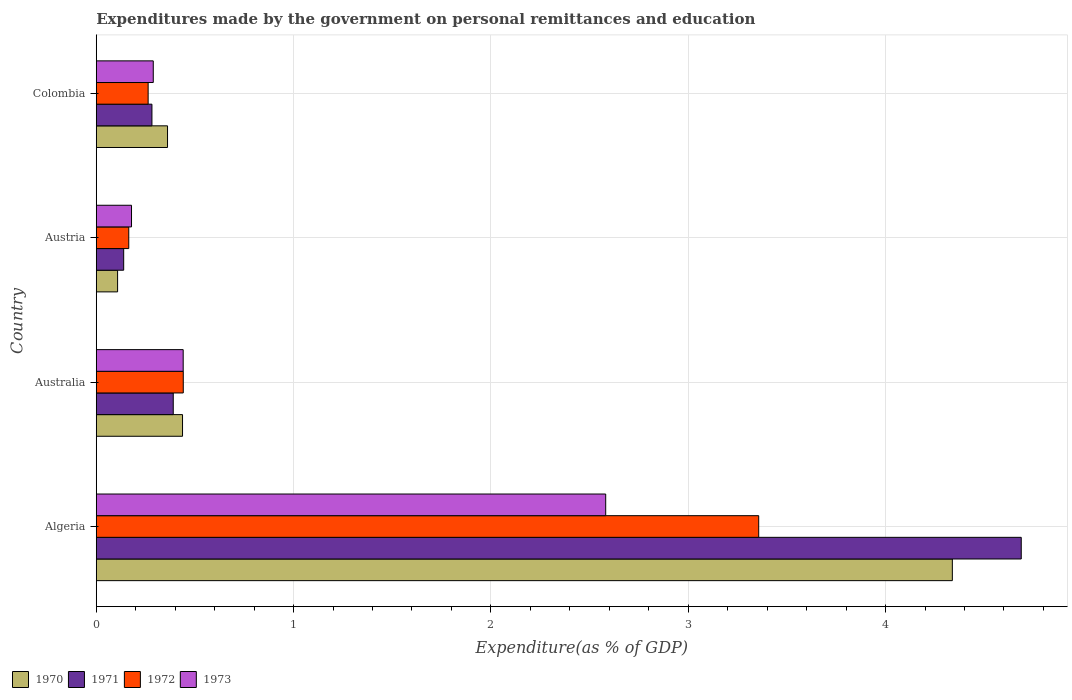How many groups of bars are there?
Ensure brevity in your answer.  4. How many bars are there on the 3rd tick from the bottom?
Your answer should be very brief. 4. In how many cases, is the number of bars for a given country not equal to the number of legend labels?
Provide a short and direct response. 0. What is the expenditures made by the government on personal remittances and education in 1970 in Australia?
Make the answer very short. 0.44. Across all countries, what is the maximum expenditures made by the government on personal remittances and education in 1971?
Make the answer very short. 4.69. Across all countries, what is the minimum expenditures made by the government on personal remittances and education in 1970?
Ensure brevity in your answer.  0.11. In which country was the expenditures made by the government on personal remittances and education in 1972 maximum?
Make the answer very short. Algeria. In which country was the expenditures made by the government on personal remittances and education in 1973 minimum?
Offer a terse response. Austria. What is the total expenditures made by the government on personal remittances and education in 1972 in the graph?
Your answer should be very brief. 4.23. What is the difference between the expenditures made by the government on personal remittances and education in 1970 in Australia and that in Colombia?
Give a very brief answer. 0.08. What is the difference between the expenditures made by the government on personal remittances and education in 1970 in Australia and the expenditures made by the government on personal remittances and education in 1972 in Algeria?
Provide a short and direct response. -2.92. What is the average expenditures made by the government on personal remittances and education in 1972 per country?
Give a very brief answer. 1.06. What is the difference between the expenditures made by the government on personal remittances and education in 1971 and expenditures made by the government on personal remittances and education in 1970 in Austria?
Provide a succinct answer. 0.03. What is the ratio of the expenditures made by the government on personal remittances and education in 1972 in Austria to that in Colombia?
Offer a very short reply. 0.63. Is the expenditures made by the government on personal remittances and education in 1972 in Australia less than that in Colombia?
Provide a succinct answer. No. What is the difference between the highest and the second highest expenditures made by the government on personal remittances and education in 1972?
Give a very brief answer. 2.92. What is the difference between the highest and the lowest expenditures made by the government on personal remittances and education in 1972?
Your response must be concise. 3.19. What does the 4th bar from the top in Algeria represents?
Provide a succinct answer. 1970. Is it the case that in every country, the sum of the expenditures made by the government on personal remittances and education in 1973 and expenditures made by the government on personal remittances and education in 1970 is greater than the expenditures made by the government on personal remittances and education in 1971?
Keep it short and to the point. Yes. How many bars are there?
Your response must be concise. 16. Are the values on the major ticks of X-axis written in scientific E-notation?
Your answer should be very brief. No. How many legend labels are there?
Give a very brief answer. 4. What is the title of the graph?
Ensure brevity in your answer.  Expenditures made by the government on personal remittances and education. What is the label or title of the X-axis?
Your answer should be very brief. Expenditure(as % of GDP). What is the label or title of the Y-axis?
Offer a terse response. Country. What is the Expenditure(as % of GDP) of 1970 in Algeria?
Offer a terse response. 4.34. What is the Expenditure(as % of GDP) in 1971 in Algeria?
Make the answer very short. 4.69. What is the Expenditure(as % of GDP) of 1972 in Algeria?
Keep it short and to the point. 3.36. What is the Expenditure(as % of GDP) in 1973 in Algeria?
Your response must be concise. 2.58. What is the Expenditure(as % of GDP) of 1970 in Australia?
Offer a terse response. 0.44. What is the Expenditure(as % of GDP) of 1971 in Australia?
Offer a very short reply. 0.39. What is the Expenditure(as % of GDP) in 1972 in Australia?
Provide a short and direct response. 0.44. What is the Expenditure(as % of GDP) in 1973 in Australia?
Offer a terse response. 0.44. What is the Expenditure(as % of GDP) of 1970 in Austria?
Your answer should be compact. 0.11. What is the Expenditure(as % of GDP) in 1971 in Austria?
Provide a succinct answer. 0.14. What is the Expenditure(as % of GDP) of 1972 in Austria?
Ensure brevity in your answer.  0.16. What is the Expenditure(as % of GDP) of 1973 in Austria?
Make the answer very short. 0.18. What is the Expenditure(as % of GDP) of 1970 in Colombia?
Provide a short and direct response. 0.36. What is the Expenditure(as % of GDP) in 1971 in Colombia?
Offer a very short reply. 0.28. What is the Expenditure(as % of GDP) of 1972 in Colombia?
Keep it short and to the point. 0.26. What is the Expenditure(as % of GDP) in 1973 in Colombia?
Make the answer very short. 0.29. Across all countries, what is the maximum Expenditure(as % of GDP) of 1970?
Provide a succinct answer. 4.34. Across all countries, what is the maximum Expenditure(as % of GDP) in 1971?
Keep it short and to the point. 4.69. Across all countries, what is the maximum Expenditure(as % of GDP) of 1972?
Make the answer very short. 3.36. Across all countries, what is the maximum Expenditure(as % of GDP) of 1973?
Provide a short and direct response. 2.58. Across all countries, what is the minimum Expenditure(as % of GDP) of 1970?
Provide a short and direct response. 0.11. Across all countries, what is the minimum Expenditure(as % of GDP) in 1971?
Give a very brief answer. 0.14. Across all countries, what is the minimum Expenditure(as % of GDP) of 1972?
Keep it short and to the point. 0.16. Across all countries, what is the minimum Expenditure(as % of GDP) of 1973?
Give a very brief answer. 0.18. What is the total Expenditure(as % of GDP) of 1970 in the graph?
Provide a short and direct response. 5.24. What is the total Expenditure(as % of GDP) in 1971 in the graph?
Your answer should be very brief. 5.5. What is the total Expenditure(as % of GDP) of 1972 in the graph?
Offer a terse response. 4.23. What is the total Expenditure(as % of GDP) in 1973 in the graph?
Offer a terse response. 3.49. What is the difference between the Expenditure(as % of GDP) in 1970 in Algeria and that in Australia?
Your answer should be very brief. 3.9. What is the difference between the Expenditure(as % of GDP) in 1971 in Algeria and that in Australia?
Offer a very short reply. 4.3. What is the difference between the Expenditure(as % of GDP) in 1972 in Algeria and that in Australia?
Keep it short and to the point. 2.92. What is the difference between the Expenditure(as % of GDP) of 1973 in Algeria and that in Australia?
Provide a short and direct response. 2.14. What is the difference between the Expenditure(as % of GDP) of 1970 in Algeria and that in Austria?
Your answer should be very brief. 4.23. What is the difference between the Expenditure(as % of GDP) in 1971 in Algeria and that in Austria?
Your answer should be very brief. 4.55. What is the difference between the Expenditure(as % of GDP) of 1972 in Algeria and that in Austria?
Provide a short and direct response. 3.19. What is the difference between the Expenditure(as % of GDP) of 1973 in Algeria and that in Austria?
Keep it short and to the point. 2.4. What is the difference between the Expenditure(as % of GDP) in 1970 in Algeria and that in Colombia?
Your answer should be very brief. 3.98. What is the difference between the Expenditure(as % of GDP) of 1971 in Algeria and that in Colombia?
Provide a short and direct response. 4.41. What is the difference between the Expenditure(as % of GDP) of 1972 in Algeria and that in Colombia?
Your response must be concise. 3.09. What is the difference between the Expenditure(as % of GDP) in 1973 in Algeria and that in Colombia?
Make the answer very short. 2.29. What is the difference between the Expenditure(as % of GDP) in 1970 in Australia and that in Austria?
Keep it short and to the point. 0.33. What is the difference between the Expenditure(as % of GDP) of 1971 in Australia and that in Austria?
Make the answer very short. 0.25. What is the difference between the Expenditure(as % of GDP) of 1972 in Australia and that in Austria?
Offer a very short reply. 0.28. What is the difference between the Expenditure(as % of GDP) in 1973 in Australia and that in Austria?
Provide a short and direct response. 0.26. What is the difference between the Expenditure(as % of GDP) of 1970 in Australia and that in Colombia?
Give a very brief answer. 0.08. What is the difference between the Expenditure(as % of GDP) in 1971 in Australia and that in Colombia?
Offer a terse response. 0.11. What is the difference between the Expenditure(as % of GDP) in 1972 in Australia and that in Colombia?
Make the answer very short. 0.18. What is the difference between the Expenditure(as % of GDP) in 1973 in Australia and that in Colombia?
Your answer should be very brief. 0.15. What is the difference between the Expenditure(as % of GDP) in 1970 in Austria and that in Colombia?
Ensure brevity in your answer.  -0.25. What is the difference between the Expenditure(as % of GDP) of 1971 in Austria and that in Colombia?
Ensure brevity in your answer.  -0.14. What is the difference between the Expenditure(as % of GDP) in 1972 in Austria and that in Colombia?
Make the answer very short. -0.1. What is the difference between the Expenditure(as % of GDP) in 1973 in Austria and that in Colombia?
Your answer should be very brief. -0.11. What is the difference between the Expenditure(as % of GDP) in 1970 in Algeria and the Expenditure(as % of GDP) in 1971 in Australia?
Offer a terse response. 3.95. What is the difference between the Expenditure(as % of GDP) in 1970 in Algeria and the Expenditure(as % of GDP) in 1972 in Australia?
Make the answer very short. 3.9. What is the difference between the Expenditure(as % of GDP) of 1970 in Algeria and the Expenditure(as % of GDP) of 1973 in Australia?
Offer a terse response. 3.9. What is the difference between the Expenditure(as % of GDP) in 1971 in Algeria and the Expenditure(as % of GDP) in 1972 in Australia?
Ensure brevity in your answer.  4.25. What is the difference between the Expenditure(as % of GDP) of 1971 in Algeria and the Expenditure(as % of GDP) of 1973 in Australia?
Your answer should be compact. 4.25. What is the difference between the Expenditure(as % of GDP) of 1972 in Algeria and the Expenditure(as % of GDP) of 1973 in Australia?
Your answer should be compact. 2.92. What is the difference between the Expenditure(as % of GDP) of 1970 in Algeria and the Expenditure(as % of GDP) of 1971 in Austria?
Your answer should be compact. 4.2. What is the difference between the Expenditure(as % of GDP) of 1970 in Algeria and the Expenditure(as % of GDP) of 1972 in Austria?
Your answer should be very brief. 4.17. What is the difference between the Expenditure(as % of GDP) in 1970 in Algeria and the Expenditure(as % of GDP) in 1973 in Austria?
Your response must be concise. 4.16. What is the difference between the Expenditure(as % of GDP) in 1971 in Algeria and the Expenditure(as % of GDP) in 1972 in Austria?
Ensure brevity in your answer.  4.52. What is the difference between the Expenditure(as % of GDP) in 1971 in Algeria and the Expenditure(as % of GDP) in 1973 in Austria?
Give a very brief answer. 4.51. What is the difference between the Expenditure(as % of GDP) in 1972 in Algeria and the Expenditure(as % of GDP) in 1973 in Austria?
Ensure brevity in your answer.  3.18. What is the difference between the Expenditure(as % of GDP) of 1970 in Algeria and the Expenditure(as % of GDP) of 1971 in Colombia?
Provide a short and direct response. 4.06. What is the difference between the Expenditure(as % of GDP) in 1970 in Algeria and the Expenditure(as % of GDP) in 1972 in Colombia?
Offer a very short reply. 4.08. What is the difference between the Expenditure(as % of GDP) of 1970 in Algeria and the Expenditure(as % of GDP) of 1973 in Colombia?
Keep it short and to the point. 4.05. What is the difference between the Expenditure(as % of GDP) of 1971 in Algeria and the Expenditure(as % of GDP) of 1972 in Colombia?
Your answer should be compact. 4.42. What is the difference between the Expenditure(as % of GDP) of 1971 in Algeria and the Expenditure(as % of GDP) of 1973 in Colombia?
Your response must be concise. 4.4. What is the difference between the Expenditure(as % of GDP) in 1972 in Algeria and the Expenditure(as % of GDP) in 1973 in Colombia?
Provide a succinct answer. 3.07. What is the difference between the Expenditure(as % of GDP) of 1970 in Australia and the Expenditure(as % of GDP) of 1971 in Austria?
Keep it short and to the point. 0.3. What is the difference between the Expenditure(as % of GDP) in 1970 in Australia and the Expenditure(as % of GDP) in 1972 in Austria?
Offer a very short reply. 0.27. What is the difference between the Expenditure(as % of GDP) of 1970 in Australia and the Expenditure(as % of GDP) of 1973 in Austria?
Provide a succinct answer. 0.26. What is the difference between the Expenditure(as % of GDP) of 1971 in Australia and the Expenditure(as % of GDP) of 1972 in Austria?
Your response must be concise. 0.23. What is the difference between the Expenditure(as % of GDP) of 1971 in Australia and the Expenditure(as % of GDP) of 1973 in Austria?
Offer a very short reply. 0.21. What is the difference between the Expenditure(as % of GDP) in 1972 in Australia and the Expenditure(as % of GDP) in 1973 in Austria?
Offer a very short reply. 0.26. What is the difference between the Expenditure(as % of GDP) of 1970 in Australia and the Expenditure(as % of GDP) of 1971 in Colombia?
Ensure brevity in your answer.  0.15. What is the difference between the Expenditure(as % of GDP) in 1970 in Australia and the Expenditure(as % of GDP) in 1972 in Colombia?
Your response must be concise. 0.17. What is the difference between the Expenditure(as % of GDP) in 1970 in Australia and the Expenditure(as % of GDP) in 1973 in Colombia?
Your response must be concise. 0.15. What is the difference between the Expenditure(as % of GDP) in 1971 in Australia and the Expenditure(as % of GDP) in 1972 in Colombia?
Offer a very short reply. 0.13. What is the difference between the Expenditure(as % of GDP) in 1971 in Australia and the Expenditure(as % of GDP) in 1973 in Colombia?
Your answer should be very brief. 0.1. What is the difference between the Expenditure(as % of GDP) of 1972 in Australia and the Expenditure(as % of GDP) of 1973 in Colombia?
Offer a terse response. 0.15. What is the difference between the Expenditure(as % of GDP) in 1970 in Austria and the Expenditure(as % of GDP) in 1971 in Colombia?
Offer a terse response. -0.17. What is the difference between the Expenditure(as % of GDP) of 1970 in Austria and the Expenditure(as % of GDP) of 1972 in Colombia?
Make the answer very short. -0.15. What is the difference between the Expenditure(as % of GDP) of 1970 in Austria and the Expenditure(as % of GDP) of 1973 in Colombia?
Provide a succinct answer. -0.18. What is the difference between the Expenditure(as % of GDP) in 1971 in Austria and the Expenditure(as % of GDP) in 1972 in Colombia?
Your response must be concise. -0.12. What is the difference between the Expenditure(as % of GDP) of 1971 in Austria and the Expenditure(as % of GDP) of 1973 in Colombia?
Ensure brevity in your answer.  -0.15. What is the difference between the Expenditure(as % of GDP) of 1972 in Austria and the Expenditure(as % of GDP) of 1973 in Colombia?
Provide a short and direct response. -0.12. What is the average Expenditure(as % of GDP) in 1970 per country?
Give a very brief answer. 1.31. What is the average Expenditure(as % of GDP) of 1971 per country?
Offer a terse response. 1.37. What is the average Expenditure(as % of GDP) in 1972 per country?
Your answer should be compact. 1.06. What is the average Expenditure(as % of GDP) of 1973 per country?
Ensure brevity in your answer.  0.87. What is the difference between the Expenditure(as % of GDP) of 1970 and Expenditure(as % of GDP) of 1971 in Algeria?
Your answer should be compact. -0.35. What is the difference between the Expenditure(as % of GDP) of 1970 and Expenditure(as % of GDP) of 1972 in Algeria?
Ensure brevity in your answer.  0.98. What is the difference between the Expenditure(as % of GDP) of 1970 and Expenditure(as % of GDP) of 1973 in Algeria?
Provide a short and direct response. 1.76. What is the difference between the Expenditure(as % of GDP) in 1971 and Expenditure(as % of GDP) in 1972 in Algeria?
Your response must be concise. 1.33. What is the difference between the Expenditure(as % of GDP) in 1971 and Expenditure(as % of GDP) in 1973 in Algeria?
Offer a terse response. 2.11. What is the difference between the Expenditure(as % of GDP) of 1972 and Expenditure(as % of GDP) of 1973 in Algeria?
Your response must be concise. 0.78. What is the difference between the Expenditure(as % of GDP) in 1970 and Expenditure(as % of GDP) in 1971 in Australia?
Your answer should be very brief. 0.05. What is the difference between the Expenditure(as % of GDP) in 1970 and Expenditure(as % of GDP) in 1972 in Australia?
Your response must be concise. -0. What is the difference between the Expenditure(as % of GDP) in 1970 and Expenditure(as % of GDP) in 1973 in Australia?
Ensure brevity in your answer.  -0. What is the difference between the Expenditure(as % of GDP) in 1971 and Expenditure(as % of GDP) in 1972 in Australia?
Your response must be concise. -0.05. What is the difference between the Expenditure(as % of GDP) in 1971 and Expenditure(as % of GDP) in 1973 in Australia?
Offer a terse response. -0.05. What is the difference between the Expenditure(as % of GDP) of 1972 and Expenditure(as % of GDP) of 1973 in Australia?
Your answer should be compact. 0. What is the difference between the Expenditure(as % of GDP) of 1970 and Expenditure(as % of GDP) of 1971 in Austria?
Provide a short and direct response. -0.03. What is the difference between the Expenditure(as % of GDP) in 1970 and Expenditure(as % of GDP) in 1972 in Austria?
Make the answer very short. -0.06. What is the difference between the Expenditure(as % of GDP) of 1970 and Expenditure(as % of GDP) of 1973 in Austria?
Offer a terse response. -0.07. What is the difference between the Expenditure(as % of GDP) in 1971 and Expenditure(as % of GDP) in 1972 in Austria?
Offer a very short reply. -0.03. What is the difference between the Expenditure(as % of GDP) of 1971 and Expenditure(as % of GDP) of 1973 in Austria?
Make the answer very short. -0.04. What is the difference between the Expenditure(as % of GDP) in 1972 and Expenditure(as % of GDP) in 1973 in Austria?
Provide a succinct answer. -0.01. What is the difference between the Expenditure(as % of GDP) in 1970 and Expenditure(as % of GDP) in 1971 in Colombia?
Provide a succinct answer. 0.08. What is the difference between the Expenditure(as % of GDP) in 1970 and Expenditure(as % of GDP) in 1972 in Colombia?
Give a very brief answer. 0.1. What is the difference between the Expenditure(as % of GDP) in 1970 and Expenditure(as % of GDP) in 1973 in Colombia?
Ensure brevity in your answer.  0.07. What is the difference between the Expenditure(as % of GDP) in 1971 and Expenditure(as % of GDP) in 1972 in Colombia?
Offer a very short reply. 0.02. What is the difference between the Expenditure(as % of GDP) in 1971 and Expenditure(as % of GDP) in 1973 in Colombia?
Offer a very short reply. -0.01. What is the difference between the Expenditure(as % of GDP) in 1972 and Expenditure(as % of GDP) in 1973 in Colombia?
Give a very brief answer. -0.03. What is the ratio of the Expenditure(as % of GDP) in 1970 in Algeria to that in Australia?
Keep it short and to the point. 9.92. What is the ratio of the Expenditure(as % of GDP) in 1971 in Algeria to that in Australia?
Make the answer very short. 12.01. What is the ratio of the Expenditure(as % of GDP) in 1972 in Algeria to that in Australia?
Ensure brevity in your answer.  7.61. What is the ratio of the Expenditure(as % of GDP) of 1973 in Algeria to that in Australia?
Keep it short and to the point. 5.86. What is the ratio of the Expenditure(as % of GDP) of 1970 in Algeria to that in Austria?
Keep it short and to the point. 40.14. What is the ratio of the Expenditure(as % of GDP) in 1971 in Algeria to that in Austria?
Offer a terse response. 33.73. What is the ratio of the Expenditure(as % of GDP) in 1972 in Algeria to that in Austria?
Give a very brief answer. 20.38. What is the ratio of the Expenditure(as % of GDP) of 1973 in Algeria to that in Austria?
Provide a short and direct response. 14.45. What is the ratio of the Expenditure(as % of GDP) of 1970 in Algeria to that in Colombia?
Your response must be concise. 12.01. What is the ratio of the Expenditure(as % of GDP) of 1971 in Algeria to that in Colombia?
Your answer should be very brief. 16.61. What is the ratio of the Expenditure(as % of GDP) in 1972 in Algeria to that in Colombia?
Ensure brevity in your answer.  12.77. What is the ratio of the Expenditure(as % of GDP) in 1973 in Algeria to that in Colombia?
Keep it short and to the point. 8.94. What is the ratio of the Expenditure(as % of GDP) in 1970 in Australia to that in Austria?
Make the answer very short. 4.04. What is the ratio of the Expenditure(as % of GDP) of 1971 in Australia to that in Austria?
Ensure brevity in your answer.  2.81. What is the ratio of the Expenditure(as % of GDP) of 1972 in Australia to that in Austria?
Your response must be concise. 2.68. What is the ratio of the Expenditure(as % of GDP) of 1973 in Australia to that in Austria?
Keep it short and to the point. 2.47. What is the ratio of the Expenditure(as % of GDP) in 1970 in Australia to that in Colombia?
Keep it short and to the point. 1.21. What is the ratio of the Expenditure(as % of GDP) of 1971 in Australia to that in Colombia?
Ensure brevity in your answer.  1.38. What is the ratio of the Expenditure(as % of GDP) of 1972 in Australia to that in Colombia?
Your answer should be compact. 1.68. What is the ratio of the Expenditure(as % of GDP) of 1973 in Australia to that in Colombia?
Your response must be concise. 1.52. What is the ratio of the Expenditure(as % of GDP) in 1970 in Austria to that in Colombia?
Your response must be concise. 0.3. What is the ratio of the Expenditure(as % of GDP) in 1971 in Austria to that in Colombia?
Offer a terse response. 0.49. What is the ratio of the Expenditure(as % of GDP) in 1972 in Austria to that in Colombia?
Provide a short and direct response. 0.63. What is the ratio of the Expenditure(as % of GDP) of 1973 in Austria to that in Colombia?
Your answer should be compact. 0.62. What is the difference between the highest and the second highest Expenditure(as % of GDP) in 1970?
Ensure brevity in your answer.  3.9. What is the difference between the highest and the second highest Expenditure(as % of GDP) in 1971?
Offer a very short reply. 4.3. What is the difference between the highest and the second highest Expenditure(as % of GDP) of 1972?
Your response must be concise. 2.92. What is the difference between the highest and the second highest Expenditure(as % of GDP) in 1973?
Give a very brief answer. 2.14. What is the difference between the highest and the lowest Expenditure(as % of GDP) of 1970?
Your response must be concise. 4.23. What is the difference between the highest and the lowest Expenditure(as % of GDP) of 1971?
Your response must be concise. 4.55. What is the difference between the highest and the lowest Expenditure(as % of GDP) of 1972?
Your response must be concise. 3.19. What is the difference between the highest and the lowest Expenditure(as % of GDP) in 1973?
Your answer should be compact. 2.4. 